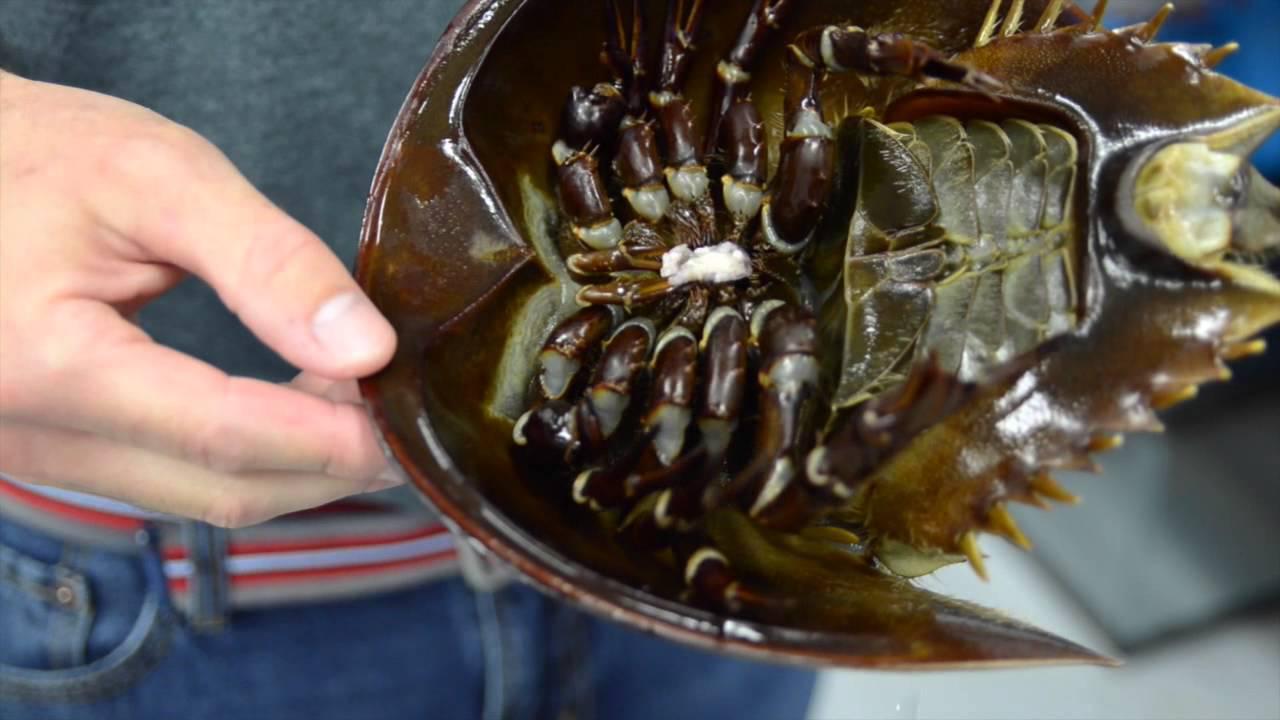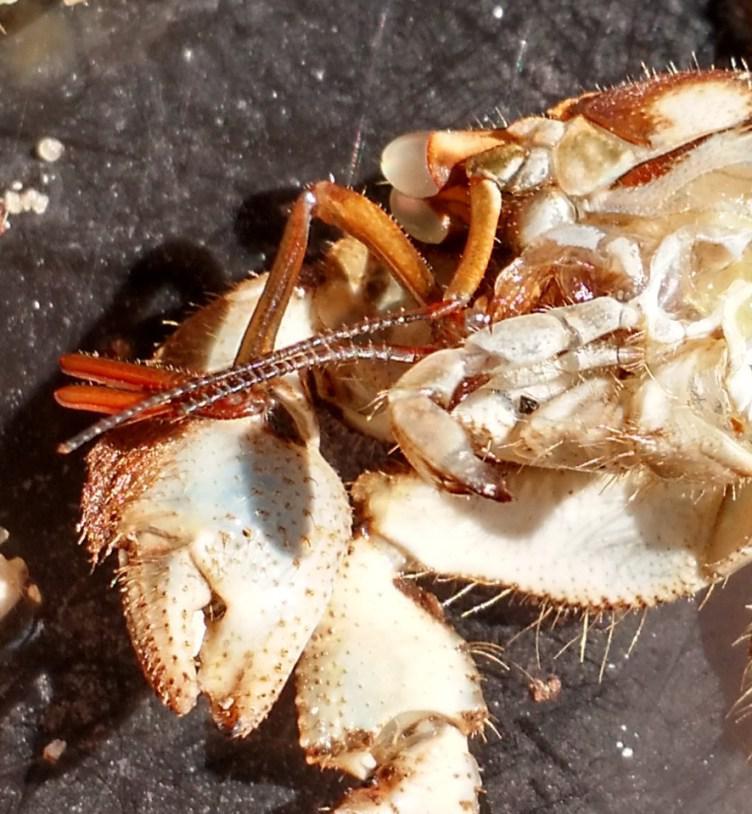The first image is the image on the left, the second image is the image on the right. For the images displayed, is the sentence "In at least one image you can see a single crab top shell, two eye and a slightly opened mouth." factually correct? Answer yes or no. No. 